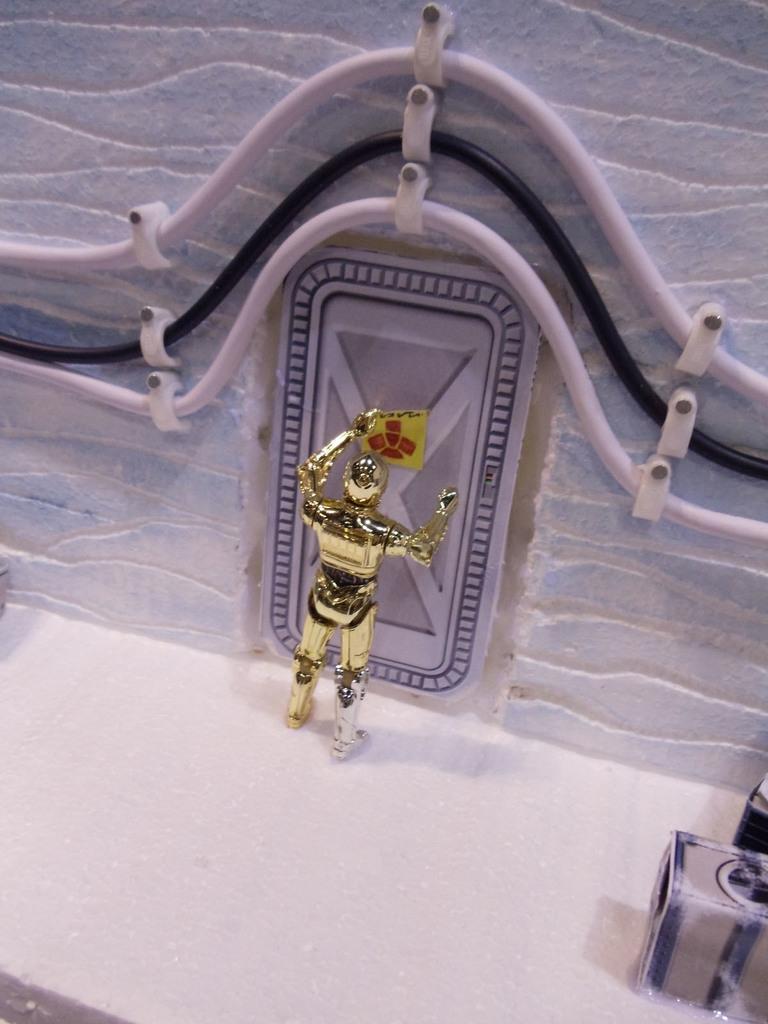Can you describe this image briefly? In the picture we can see a desk with an artificial wall with a door in front of it, we can see a sculpture of a person standing which is gold in color and holding some yellow color bit of paper in the hand. 